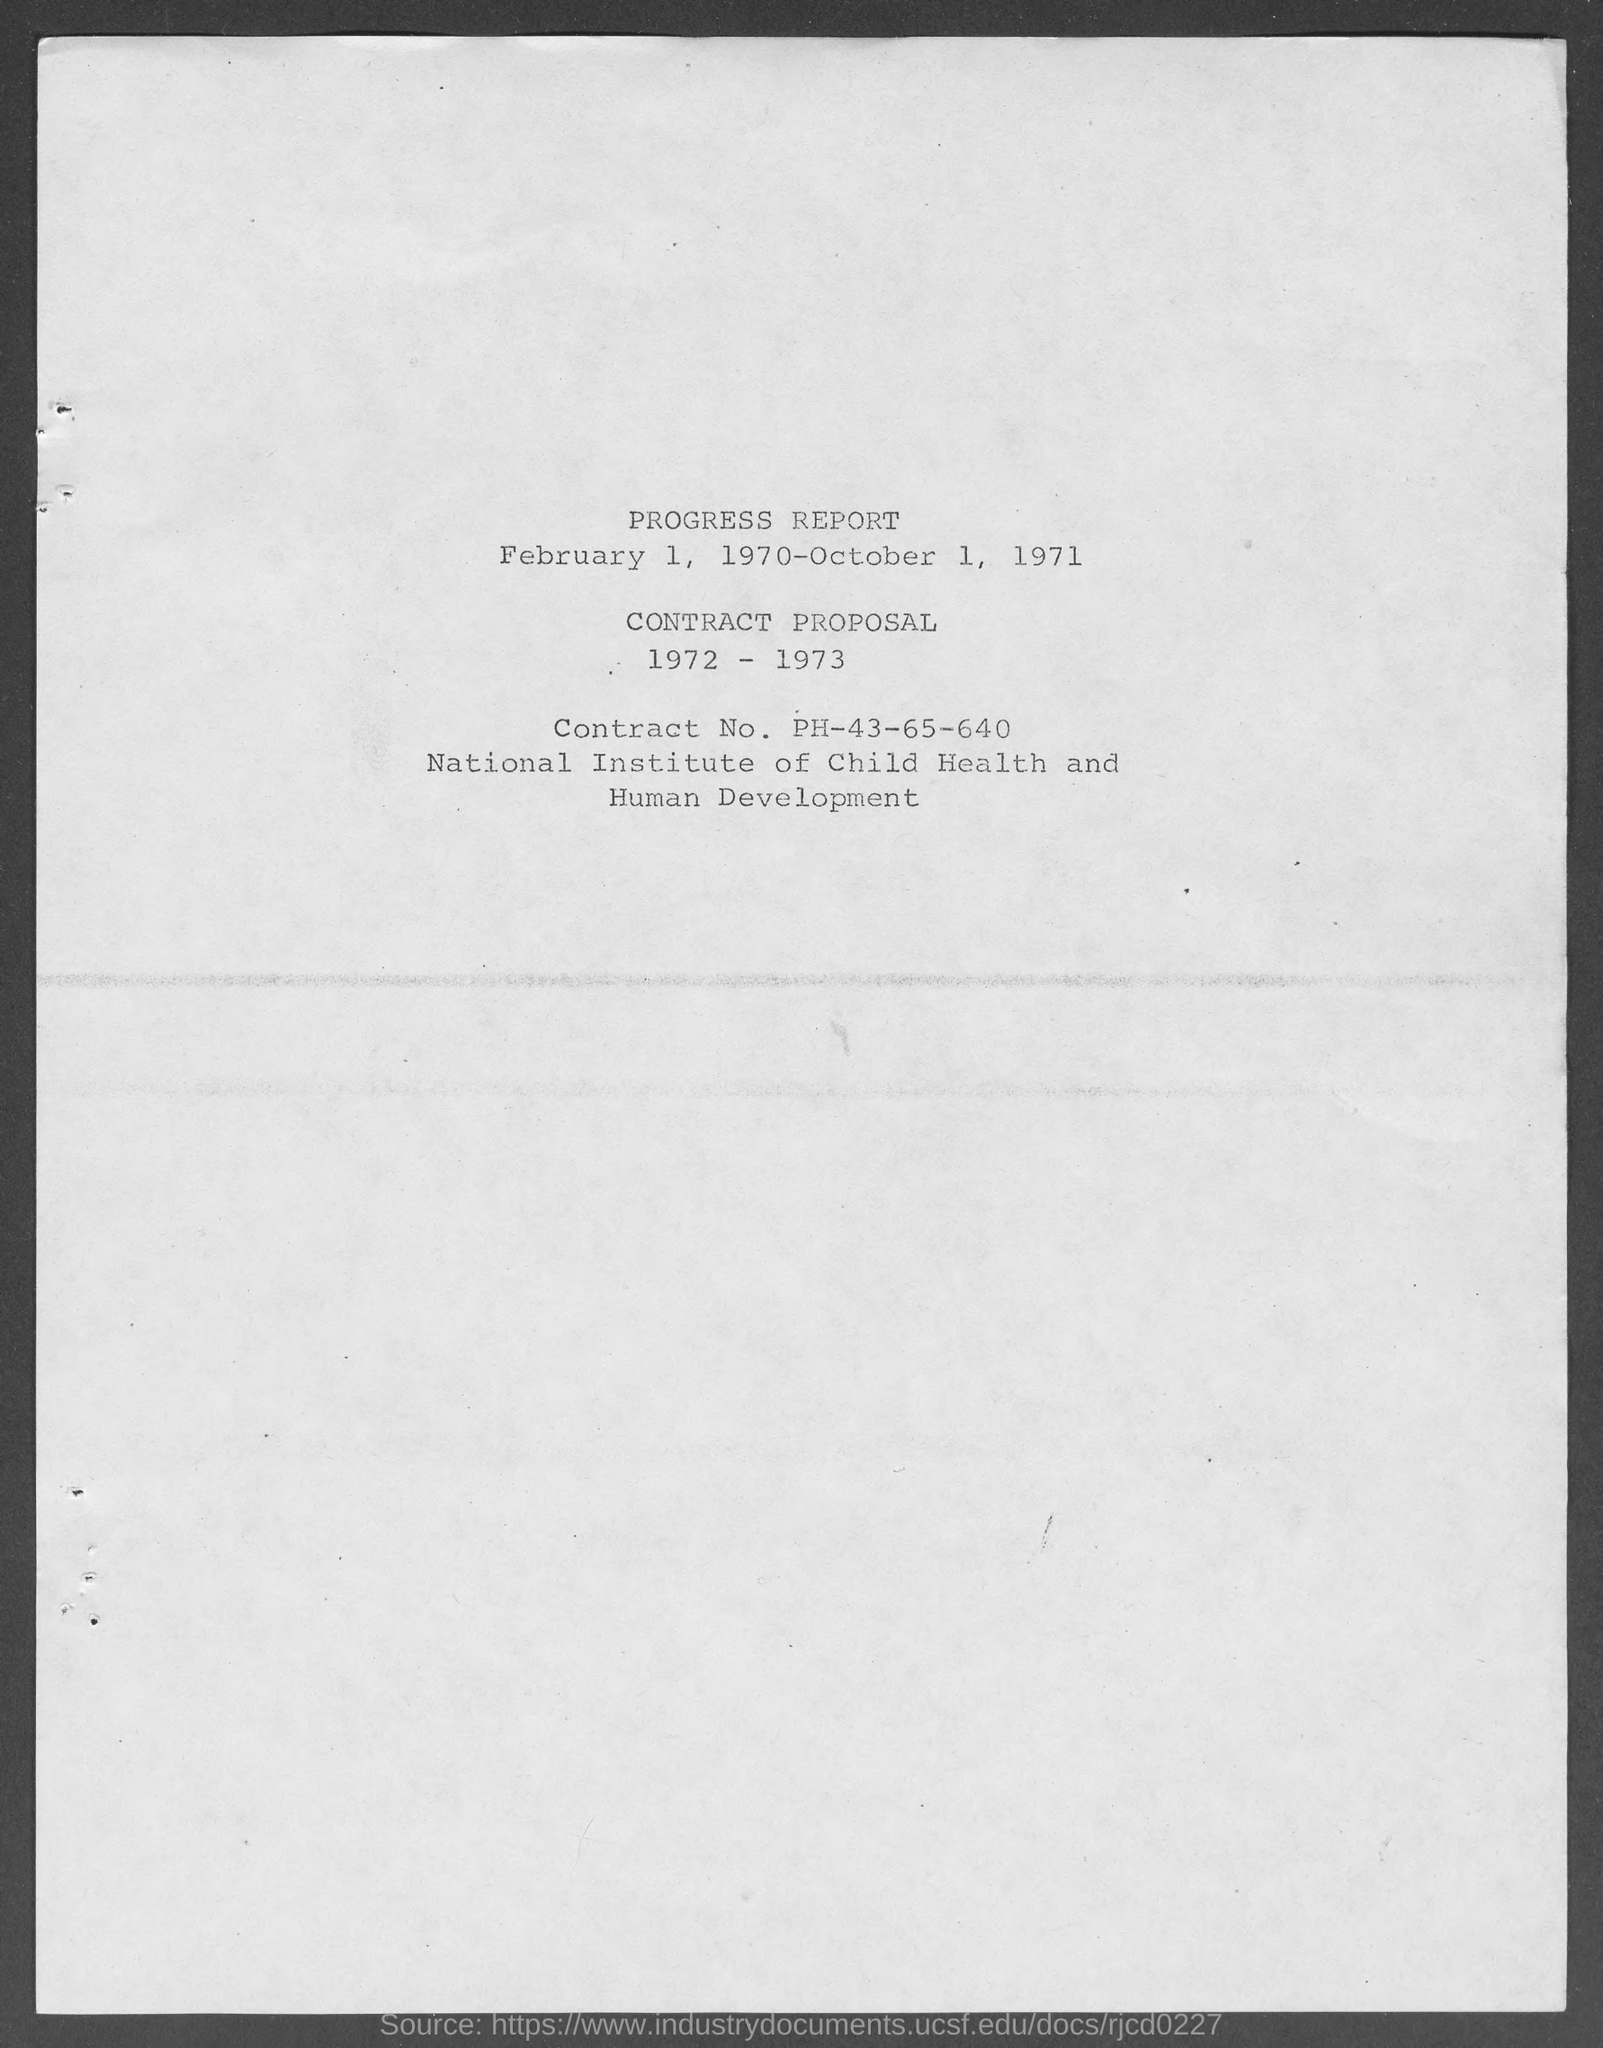Mention a couple of crucial points in this snapshot. The Contract No. of the Institution is PH-43-65-640. 